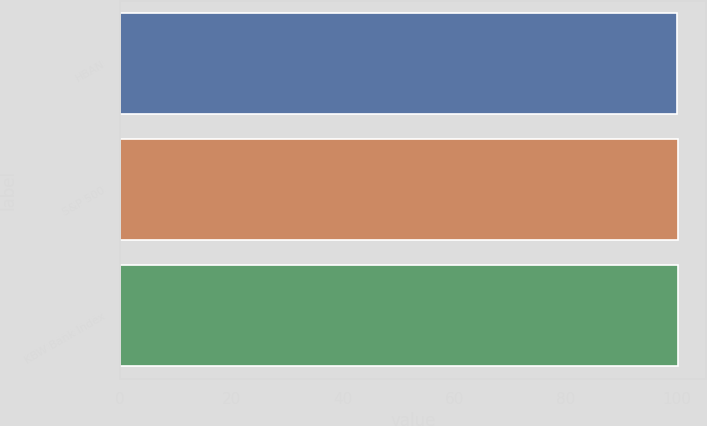<chart> <loc_0><loc_0><loc_500><loc_500><bar_chart><fcel>HBAN<fcel>S&P 500<fcel>KBW Bank Index<nl><fcel>100<fcel>100.1<fcel>100.2<nl></chart> 